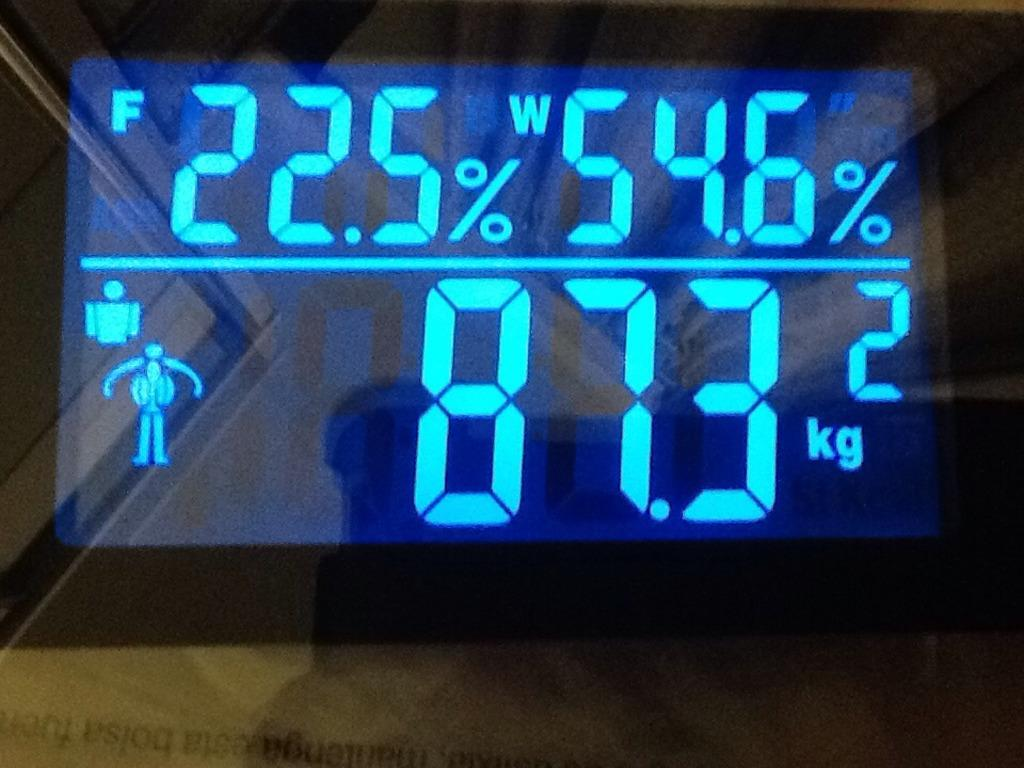<image>
Write a terse but informative summary of the picture. Digital electronic blue display with the current kg on it. 